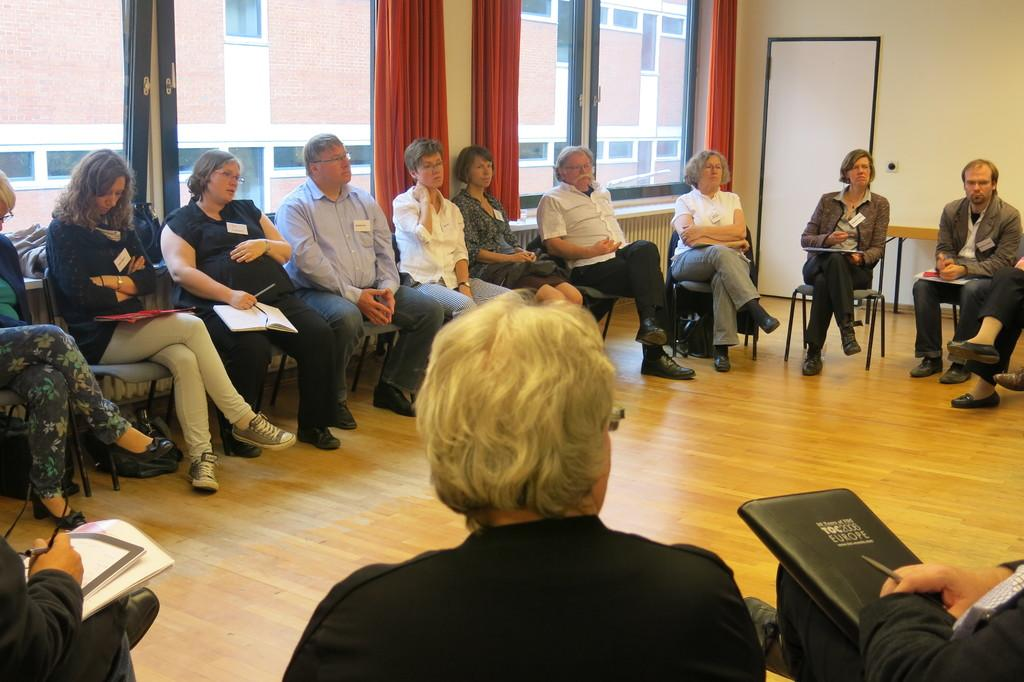What type of furniture is present in the image? There is a table in the image. What are the people sitting on in the image? There are people sitting on chairs in the image. What type of windows can be seen in the image? There are glass windows in the image. What type of window treatment is present in the image? There are curtains in the image. What shape is the condition of the limit in the image? There is no mention of a condition or limit in the image; it features a table, chairs, glass windows, and curtains. 